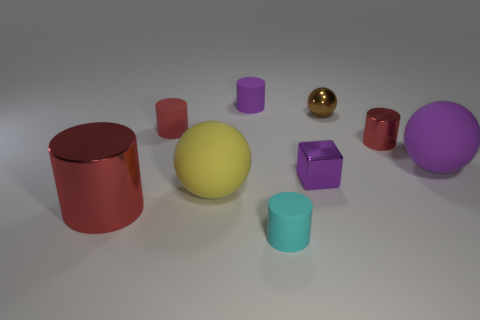What size is the metallic cylinder that is the same color as the large shiny object?
Offer a terse response. Small. What is the shape of the big matte object that is the same color as the tiny metallic cube?
Your answer should be very brief. Sphere. How many rubber things are small cylinders or large blue blocks?
Your response must be concise. 3. What is the color of the large matte sphere in front of the large rubber ball to the right of the cylinder that is on the right side of the cube?
Ensure brevity in your answer.  Yellow. The small shiny object that is the same shape as the big red thing is what color?
Make the answer very short. Red. Is there anything else that has the same color as the metallic ball?
Provide a short and direct response. No. How many other things are made of the same material as the large red thing?
Offer a terse response. 3. What size is the purple ball?
Give a very brief answer. Large. Are there any tiny metal things of the same shape as the tiny purple matte object?
Your answer should be compact. Yes. What number of objects are tiny objects or small matte things on the right side of the purple cylinder?
Make the answer very short. 6. 